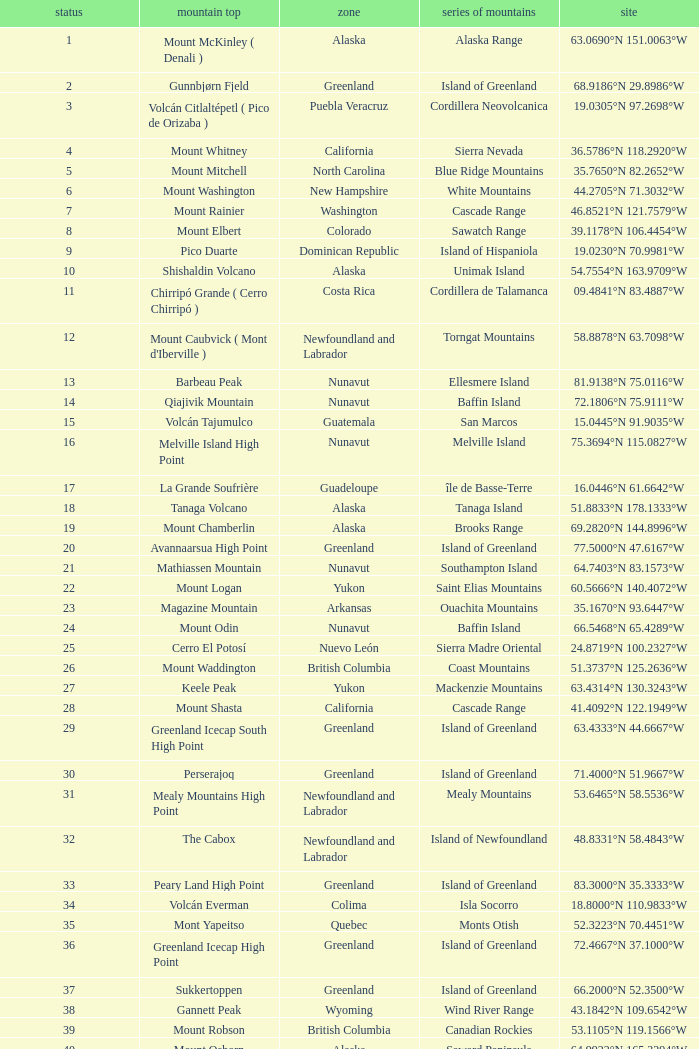Which Mountain Range has a Region of haiti, and a Location of 18.3601°n 71.9764°w? Island of Hispaniola. 